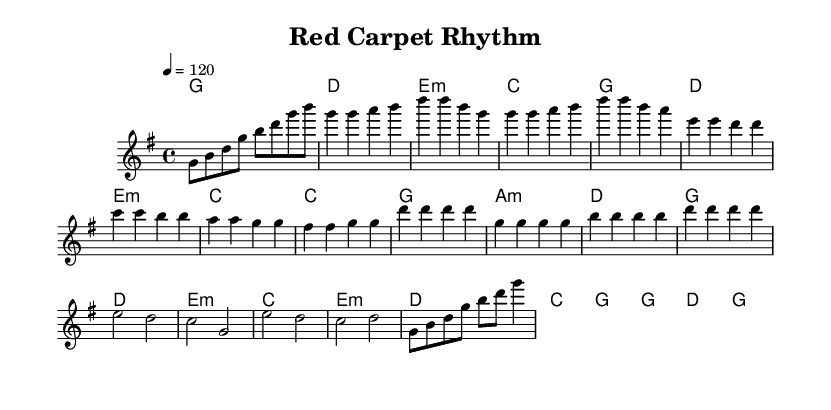What is the key signature of this music? The key signature is G major, which has one sharp (F#). This is indicated at the beginning of the sheet music within the global context.
Answer: G major What is the time signature of this music? The time signature is 4/4, which means there are four beats in each measure and the quarter note gets one beat. This is also noted in the global context at the beginning.
Answer: 4/4 What is the tempo marking of this music? The tempo marking indicates a speed of 120 beats per minute. This is specified in the global section under the tempo command at the start of the music.
Answer: 120 How many bars are in the chorus section? The chorus consists of four measures (or bars). By counting the measures in the chorus section, we can see it is made up of four distinct rhythmic patterns.
Answer: 4 Which part contains the lyrics "Red carpet rhythm, premiere night glamour"? The lyrics "Red carpet rhythm, premiere night glamour" are found in the chorus section. This can be verified by looking at the lyric mode corresponding to the melody in the score.
Answer: Chorus What is the predominant mood conveyed in the pre-chorus lyrics? The pre-chorus lyrics convey a feeling of confidence and attention, as shown by the words "feeling fine, all eyes on me." This reflects a glamorous and celebratory mood typical in K-Pop dance anthems.
Answer: Confidence What is the main theme of the song as evidenced by the lyrics? The main theme revolves around glamour and celebration at a movie premiere, emphasized through the imagery of red carpets and bright lights in the lyrics. This is a key characteristic of K-Pop dance anthems focused on such events.
Answer: Glamour 